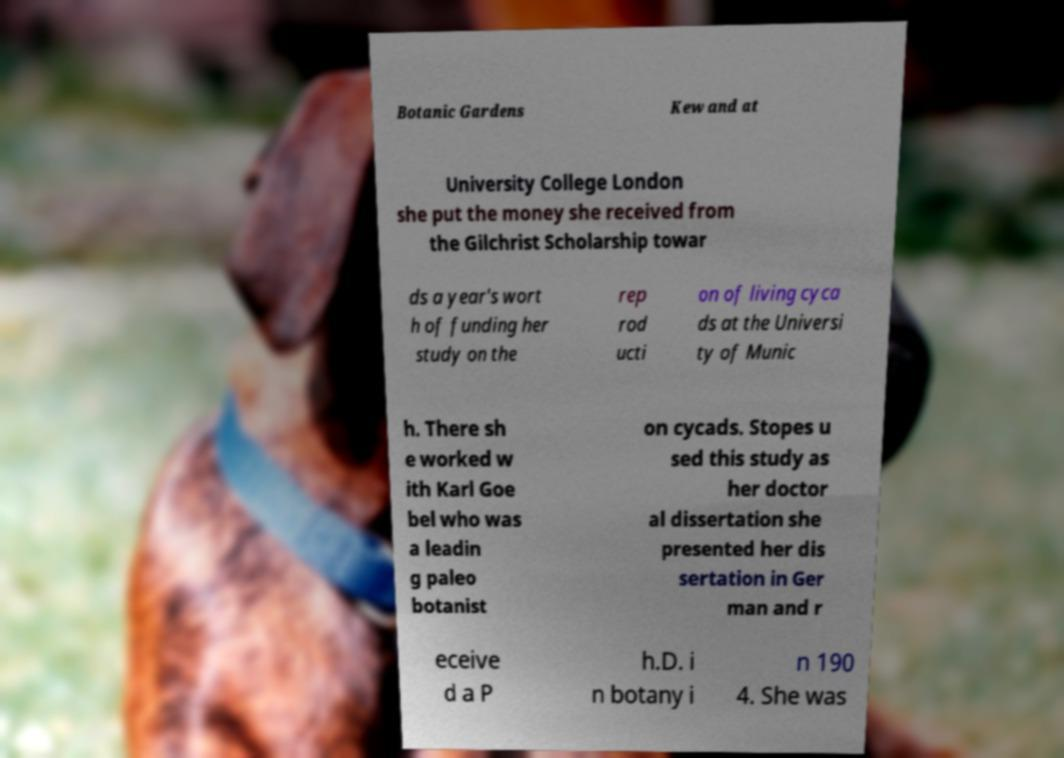Please read and relay the text visible in this image. What does it say? Botanic Gardens Kew and at University College London she put the money she received from the Gilchrist Scholarship towar ds a year's wort h of funding her study on the rep rod ucti on of living cyca ds at the Universi ty of Munic h. There sh e worked w ith Karl Goe bel who was a leadin g paleo botanist on cycads. Stopes u sed this study as her doctor al dissertation she presented her dis sertation in Ger man and r eceive d a P h.D. i n botany i n 190 4. She was 